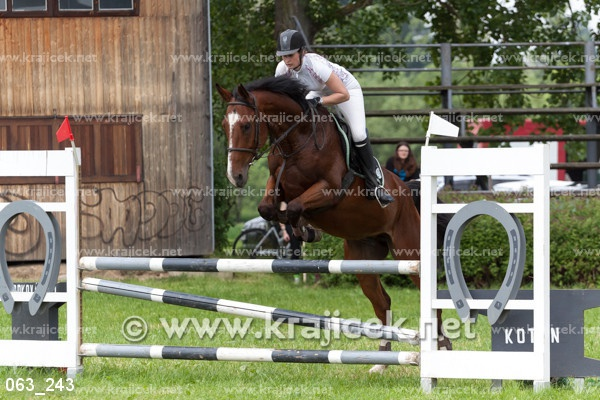Describe the objects in this image and their specific colors. I can see horse in gray, black, and maroon tones, people in gray, lavender, black, and darkgray tones, bicycle in gray, black, and darkgreen tones, and people in gray, black, maroon, and brown tones in this image. 